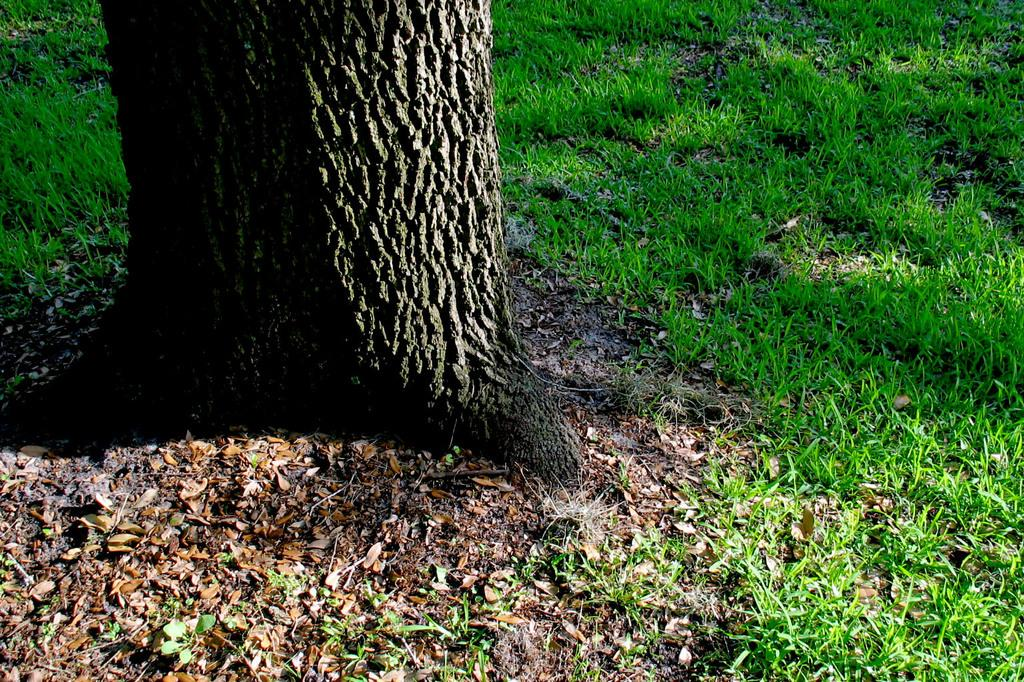What type of vegetation can be seen at the bottom of the image? There are dry leaves at the bottom side of the image. What is located in the foreground of the image? There is a trunk in the foreground. What type of terrain is visible in the foreground? There is grassland in the foreground. Can you hear the leaves crying in the image? There is no indication of sound or crying leaves in the image. How does the trunk show respect to the environment in the image? The image does not depict any actions or behaviors that could be interpreted as showing respect. 